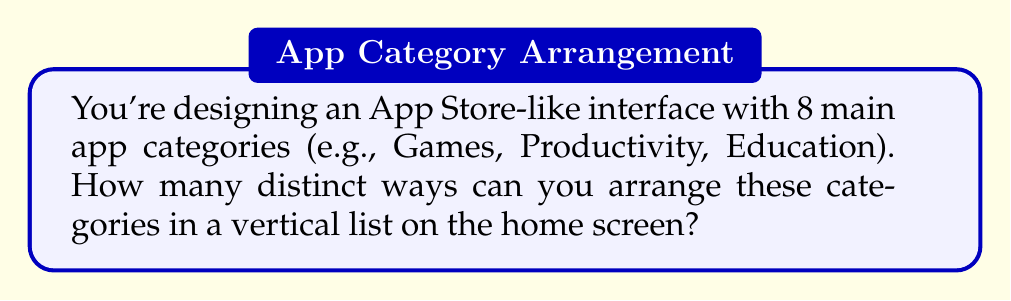Provide a solution to this math problem. Let's approach this step-by-step:

1. This problem is a straightforward permutation question. We need to arrange 8 distinct items (app categories) in a specific order.

2. In permutation problems, the order matters. For example, having "Games" at the top is different from having "Games" at the bottom.

3. We're using all 8 categories, so this is a permutation without repetition.

4. The formula for permutations without repetition is:

   $$P(n) = n!$$

   Where $n$ is the number of items to be arranged.

5. In this case, $n = 8$ (8 app categories).

6. So, we calculate:

   $$P(8) = 8!$$

7. Let's expand this:

   $$8! = 8 \times 7 \times 6 \times 5 \times 4 \times 3 \times 2 \times 1 = 40,320$$

Therefore, there are 40,320 distinct ways to arrange 8 app categories in a vertical list.
Answer: 40,320 